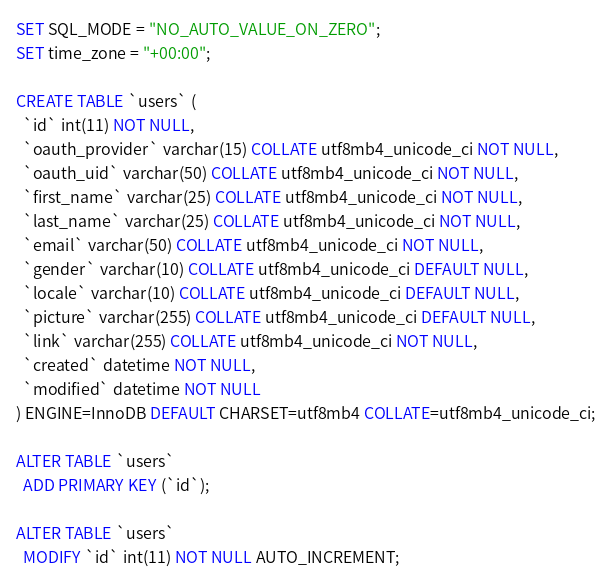Convert code to text. <code><loc_0><loc_0><loc_500><loc_500><_SQL_>SET SQL_MODE = "NO_AUTO_VALUE_ON_ZERO";
SET time_zone = "+00:00";

CREATE TABLE `users` (
  `id` int(11) NOT NULL,
  `oauth_provider` varchar(15) COLLATE utf8mb4_unicode_ci NOT NULL,
  `oauth_uid` varchar(50) COLLATE utf8mb4_unicode_ci NOT NULL,
  `first_name` varchar(25) COLLATE utf8mb4_unicode_ci NOT NULL,
  `last_name` varchar(25) COLLATE utf8mb4_unicode_ci NOT NULL,
  `email` varchar(50) COLLATE utf8mb4_unicode_ci NOT NULL,
  `gender` varchar(10) COLLATE utf8mb4_unicode_ci DEFAULT NULL,
  `locale` varchar(10) COLLATE utf8mb4_unicode_ci DEFAULT NULL,
  `picture` varchar(255) COLLATE utf8mb4_unicode_ci DEFAULT NULL,
  `link` varchar(255) COLLATE utf8mb4_unicode_ci NOT NULL,
  `created` datetime NOT NULL,
  `modified` datetime NOT NULL
) ENGINE=InnoDB DEFAULT CHARSET=utf8mb4 COLLATE=utf8mb4_unicode_ci;

ALTER TABLE `users`
  ADD PRIMARY KEY (`id`);

ALTER TABLE `users`
  MODIFY `id` int(11) NOT NULL AUTO_INCREMENT;
</code> 